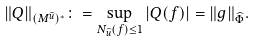Convert formula to latex. <formula><loc_0><loc_0><loc_500><loc_500>\| Q \| _ { ( M ^ { \widehat { u } } ) ^ { \ast } } \colon = { \sup _ { N _ { \widehat { u } } ( f ) \leq 1 } | Q ( f ) | } = \| g \| _ { \widehat { \Phi } } .</formula> 